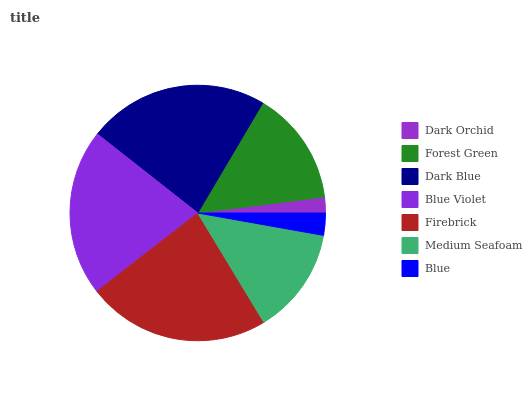Is Dark Orchid the minimum?
Answer yes or no. Yes. Is Firebrick the maximum?
Answer yes or no. Yes. Is Forest Green the minimum?
Answer yes or no. No. Is Forest Green the maximum?
Answer yes or no. No. Is Forest Green greater than Dark Orchid?
Answer yes or no. Yes. Is Dark Orchid less than Forest Green?
Answer yes or no. Yes. Is Dark Orchid greater than Forest Green?
Answer yes or no. No. Is Forest Green less than Dark Orchid?
Answer yes or no. No. Is Forest Green the high median?
Answer yes or no. Yes. Is Forest Green the low median?
Answer yes or no. Yes. Is Dark Blue the high median?
Answer yes or no. No. Is Dark Blue the low median?
Answer yes or no. No. 